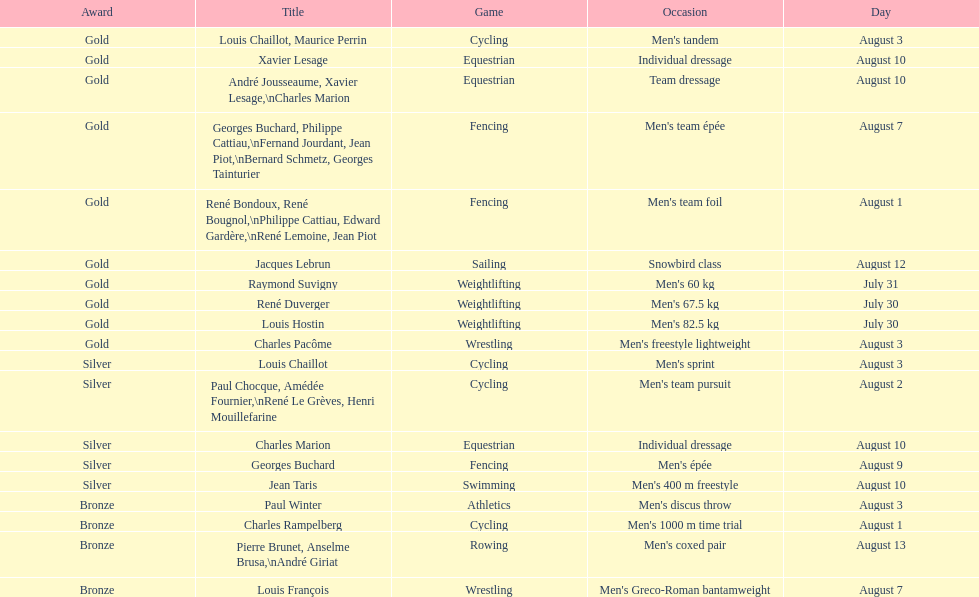How many total gold medals were won by weightlifting? 3. 